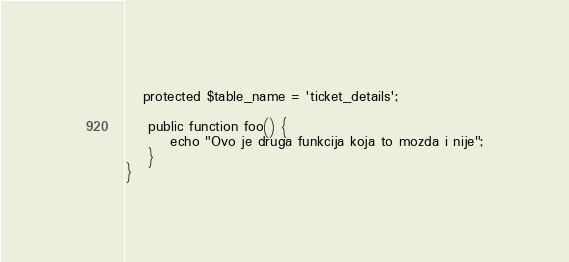Convert code to text. <code><loc_0><loc_0><loc_500><loc_500><_PHP_>   protected $table_name = 'ticket_details';

    public function foo() {
        echo "Ovo je druga funkcija koja to mozda i nije";
    }
}
</code> 